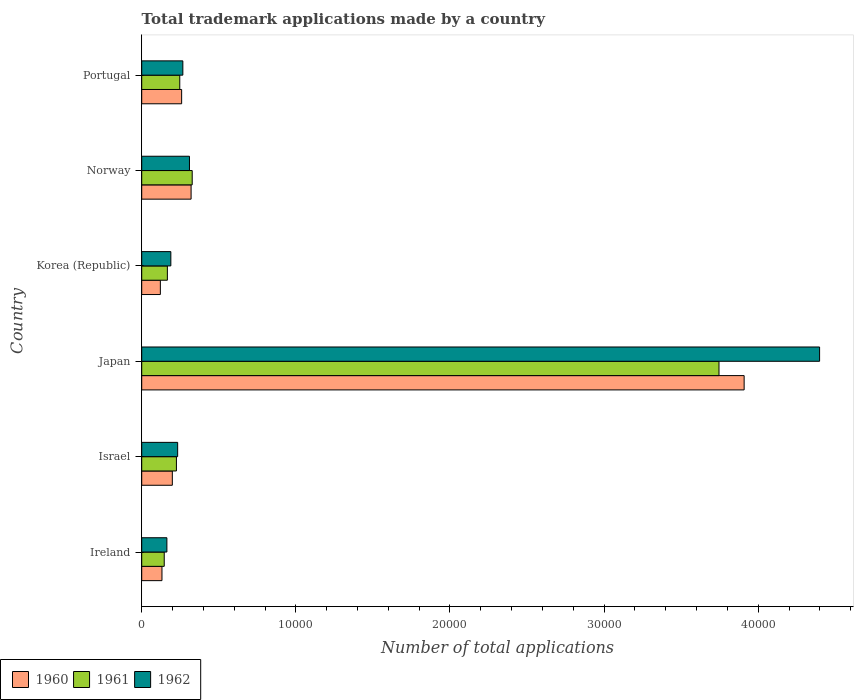How many groups of bars are there?
Give a very brief answer. 6. Are the number of bars per tick equal to the number of legend labels?
Your answer should be very brief. Yes. Are the number of bars on each tick of the Y-axis equal?
Offer a very short reply. Yes. How many bars are there on the 2nd tick from the bottom?
Offer a terse response. 3. What is the number of applications made by in 1961 in Norway?
Your answer should be very brief. 3276. Across all countries, what is the maximum number of applications made by in 1961?
Your answer should be very brief. 3.75e+04. Across all countries, what is the minimum number of applications made by in 1961?
Your answer should be very brief. 1461. What is the total number of applications made by in 1960 in the graph?
Offer a very short reply. 4.94e+04. What is the difference between the number of applications made by in 1960 in Korea (Republic) and that in Portugal?
Provide a succinct answer. -1381. What is the difference between the number of applications made by in 1961 in Israel and the number of applications made by in 1962 in Norway?
Provide a succinct answer. -846. What is the average number of applications made by in 1960 per country?
Make the answer very short. 8232. What is the difference between the number of applications made by in 1961 and number of applications made by in 1962 in Korea (Republic)?
Your answer should be compact. -225. In how many countries, is the number of applications made by in 1962 greater than 14000 ?
Provide a short and direct response. 1. What is the ratio of the number of applications made by in 1961 in Japan to that in Portugal?
Ensure brevity in your answer.  15.18. Is the number of applications made by in 1961 in Korea (Republic) less than that in Portugal?
Ensure brevity in your answer.  Yes. What is the difference between the highest and the second highest number of applications made by in 1961?
Make the answer very short. 3.42e+04. What is the difference between the highest and the lowest number of applications made by in 1962?
Offer a terse response. 4.24e+04. What does the 3rd bar from the top in Japan represents?
Provide a short and direct response. 1960. What does the 3rd bar from the bottom in Norway represents?
Keep it short and to the point. 1962. Is it the case that in every country, the sum of the number of applications made by in 1961 and number of applications made by in 1962 is greater than the number of applications made by in 1960?
Your response must be concise. Yes. How many countries are there in the graph?
Offer a terse response. 6. What is the difference between two consecutive major ticks on the X-axis?
Your answer should be very brief. 10000. Are the values on the major ticks of X-axis written in scientific E-notation?
Offer a terse response. No. Does the graph contain grids?
Offer a terse response. No. How many legend labels are there?
Your answer should be very brief. 3. How are the legend labels stacked?
Your answer should be compact. Horizontal. What is the title of the graph?
Keep it short and to the point. Total trademark applications made by a country. Does "2008" appear as one of the legend labels in the graph?
Your response must be concise. No. What is the label or title of the X-axis?
Your answer should be very brief. Number of total applications. What is the Number of total applications in 1960 in Ireland?
Your answer should be compact. 1314. What is the Number of total applications in 1961 in Ireland?
Offer a very short reply. 1461. What is the Number of total applications in 1962 in Ireland?
Keep it short and to the point. 1633. What is the Number of total applications in 1960 in Israel?
Your answer should be compact. 1986. What is the Number of total applications in 1961 in Israel?
Offer a terse response. 2252. What is the Number of total applications of 1962 in Israel?
Provide a succinct answer. 2332. What is the Number of total applications of 1960 in Japan?
Provide a short and direct response. 3.91e+04. What is the Number of total applications of 1961 in Japan?
Offer a very short reply. 3.75e+04. What is the Number of total applications in 1962 in Japan?
Offer a very short reply. 4.40e+04. What is the Number of total applications in 1960 in Korea (Republic)?
Offer a very short reply. 1209. What is the Number of total applications of 1961 in Korea (Republic)?
Offer a very short reply. 1665. What is the Number of total applications of 1962 in Korea (Republic)?
Give a very brief answer. 1890. What is the Number of total applications of 1960 in Norway?
Your response must be concise. 3204. What is the Number of total applications of 1961 in Norway?
Provide a succinct answer. 3276. What is the Number of total applications in 1962 in Norway?
Your answer should be very brief. 3098. What is the Number of total applications in 1960 in Portugal?
Offer a very short reply. 2590. What is the Number of total applications of 1961 in Portugal?
Your response must be concise. 2468. What is the Number of total applications in 1962 in Portugal?
Your answer should be compact. 2668. Across all countries, what is the maximum Number of total applications of 1960?
Keep it short and to the point. 3.91e+04. Across all countries, what is the maximum Number of total applications of 1961?
Make the answer very short. 3.75e+04. Across all countries, what is the maximum Number of total applications of 1962?
Your answer should be very brief. 4.40e+04. Across all countries, what is the minimum Number of total applications of 1960?
Keep it short and to the point. 1209. Across all countries, what is the minimum Number of total applications of 1961?
Provide a short and direct response. 1461. Across all countries, what is the minimum Number of total applications in 1962?
Give a very brief answer. 1633. What is the total Number of total applications of 1960 in the graph?
Offer a very short reply. 4.94e+04. What is the total Number of total applications of 1961 in the graph?
Offer a terse response. 4.86e+04. What is the total Number of total applications of 1962 in the graph?
Ensure brevity in your answer.  5.56e+04. What is the difference between the Number of total applications in 1960 in Ireland and that in Israel?
Keep it short and to the point. -672. What is the difference between the Number of total applications of 1961 in Ireland and that in Israel?
Your response must be concise. -791. What is the difference between the Number of total applications of 1962 in Ireland and that in Israel?
Keep it short and to the point. -699. What is the difference between the Number of total applications in 1960 in Ireland and that in Japan?
Make the answer very short. -3.78e+04. What is the difference between the Number of total applications in 1961 in Ireland and that in Japan?
Provide a succinct answer. -3.60e+04. What is the difference between the Number of total applications in 1962 in Ireland and that in Japan?
Your answer should be compact. -4.24e+04. What is the difference between the Number of total applications in 1960 in Ireland and that in Korea (Republic)?
Give a very brief answer. 105. What is the difference between the Number of total applications of 1961 in Ireland and that in Korea (Republic)?
Offer a very short reply. -204. What is the difference between the Number of total applications in 1962 in Ireland and that in Korea (Republic)?
Give a very brief answer. -257. What is the difference between the Number of total applications in 1960 in Ireland and that in Norway?
Provide a short and direct response. -1890. What is the difference between the Number of total applications in 1961 in Ireland and that in Norway?
Your response must be concise. -1815. What is the difference between the Number of total applications in 1962 in Ireland and that in Norway?
Make the answer very short. -1465. What is the difference between the Number of total applications in 1960 in Ireland and that in Portugal?
Give a very brief answer. -1276. What is the difference between the Number of total applications of 1961 in Ireland and that in Portugal?
Your answer should be very brief. -1007. What is the difference between the Number of total applications of 1962 in Ireland and that in Portugal?
Keep it short and to the point. -1035. What is the difference between the Number of total applications in 1960 in Israel and that in Japan?
Offer a very short reply. -3.71e+04. What is the difference between the Number of total applications in 1961 in Israel and that in Japan?
Provide a succinct answer. -3.52e+04. What is the difference between the Number of total applications of 1962 in Israel and that in Japan?
Your response must be concise. -4.17e+04. What is the difference between the Number of total applications of 1960 in Israel and that in Korea (Republic)?
Offer a terse response. 777. What is the difference between the Number of total applications in 1961 in Israel and that in Korea (Republic)?
Provide a short and direct response. 587. What is the difference between the Number of total applications of 1962 in Israel and that in Korea (Republic)?
Make the answer very short. 442. What is the difference between the Number of total applications in 1960 in Israel and that in Norway?
Your response must be concise. -1218. What is the difference between the Number of total applications of 1961 in Israel and that in Norway?
Offer a very short reply. -1024. What is the difference between the Number of total applications in 1962 in Israel and that in Norway?
Your answer should be compact. -766. What is the difference between the Number of total applications of 1960 in Israel and that in Portugal?
Offer a very short reply. -604. What is the difference between the Number of total applications in 1961 in Israel and that in Portugal?
Your answer should be very brief. -216. What is the difference between the Number of total applications in 1962 in Israel and that in Portugal?
Ensure brevity in your answer.  -336. What is the difference between the Number of total applications of 1960 in Japan and that in Korea (Republic)?
Offer a terse response. 3.79e+04. What is the difference between the Number of total applications in 1961 in Japan and that in Korea (Republic)?
Give a very brief answer. 3.58e+04. What is the difference between the Number of total applications in 1962 in Japan and that in Korea (Republic)?
Your answer should be very brief. 4.21e+04. What is the difference between the Number of total applications of 1960 in Japan and that in Norway?
Keep it short and to the point. 3.59e+04. What is the difference between the Number of total applications of 1961 in Japan and that in Norway?
Your response must be concise. 3.42e+04. What is the difference between the Number of total applications in 1962 in Japan and that in Norway?
Provide a succinct answer. 4.09e+04. What is the difference between the Number of total applications in 1960 in Japan and that in Portugal?
Your response must be concise. 3.65e+04. What is the difference between the Number of total applications in 1961 in Japan and that in Portugal?
Ensure brevity in your answer.  3.50e+04. What is the difference between the Number of total applications of 1962 in Japan and that in Portugal?
Provide a short and direct response. 4.13e+04. What is the difference between the Number of total applications in 1960 in Korea (Republic) and that in Norway?
Ensure brevity in your answer.  -1995. What is the difference between the Number of total applications in 1961 in Korea (Republic) and that in Norway?
Provide a short and direct response. -1611. What is the difference between the Number of total applications in 1962 in Korea (Republic) and that in Norway?
Your response must be concise. -1208. What is the difference between the Number of total applications in 1960 in Korea (Republic) and that in Portugal?
Your response must be concise. -1381. What is the difference between the Number of total applications in 1961 in Korea (Republic) and that in Portugal?
Your answer should be very brief. -803. What is the difference between the Number of total applications of 1962 in Korea (Republic) and that in Portugal?
Make the answer very short. -778. What is the difference between the Number of total applications in 1960 in Norway and that in Portugal?
Your answer should be compact. 614. What is the difference between the Number of total applications in 1961 in Norway and that in Portugal?
Provide a short and direct response. 808. What is the difference between the Number of total applications in 1962 in Norway and that in Portugal?
Provide a succinct answer. 430. What is the difference between the Number of total applications in 1960 in Ireland and the Number of total applications in 1961 in Israel?
Ensure brevity in your answer.  -938. What is the difference between the Number of total applications of 1960 in Ireland and the Number of total applications of 1962 in Israel?
Give a very brief answer. -1018. What is the difference between the Number of total applications of 1961 in Ireland and the Number of total applications of 1962 in Israel?
Offer a very short reply. -871. What is the difference between the Number of total applications of 1960 in Ireland and the Number of total applications of 1961 in Japan?
Keep it short and to the point. -3.61e+04. What is the difference between the Number of total applications of 1960 in Ireland and the Number of total applications of 1962 in Japan?
Provide a short and direct response. -4.27e+04. What is the difference between the Number of total applications of 1961 in Ireland and the Number of total applications of 1962 in Japan?
Provide a succinct answer. -4.25e+04. What is the difference between the Number of total applications in 1960 in Ireland and the Number of total applications in 1961 in Korea (Republic)?
Your answer should be very brief. -351. What is the difference between the Number of total applications in 1960 in Ireland and the Number of total applications in 1962 in Korea (Republic)?
Keep it short and to the point. -576. What is the difference between the Number of total applications in 1961 in Ireland and the Number of total applications in 1962 in Korea (Republic)?
Your answer should be very brief. -429. What is the difference between the Number of total applications in 1960 in Ireland and the Number of total applications in 1961 in Norway?
Give a very brief answer. -1962. What is the difference between the Number of total applications in 1960 in Ireland and the Number of total applications in 1962 in Norway?
Offer a terse response. -1784. What is the difference between the Number of total applications in 1961 in Ireland and the Number of total applications in 1962 in Norway?
Ensure brevity in your answer.  -1637. What is the difference between the Number of total applications of 1960 in Ireland and the Number of total applications of 1961 in Portugal?
Offer a terse response. -1154. What is the difference between the Number of total applications of 1960 in Ireland and the Number of total applications of 1962 in Portugal?
Provide a succinct answer. -1354. What is the difference between the Number of total applications in 1961 in Ireland and the Number of total applications in 1962 in Portugal?
Make the answer very short. -1207. What is the difference between the Number of total applications in 1960 in Israel and the Number of total applications in 1961 in Japan?
Make the answer very short. -3.55e+04. What is the difference between the Number of total applications of 1960 in Israel and the Number of total applications of 1962 in Japan?
Offer a terse response. -4.20e+04. What is the difference between the Number of total applications in 1961 in Israel and the Number of total applications in 1962 in Japan?
Keep it short and to the point. -4.17e+04. What is the difference between the Number of total applications of 1960 in Israel and the Number of total applications of 1961 in Korea (Republic)?
Give a very brief answer. 321. What is the difference between the Number of total applications of 1960 in Israel and the Number of total applications of 1962 in Korea (Republic)?
Your answer should be very brief. 96. What is the difference between the Number of total applications of 1961 in Israel and the Number of total applications of 1962 in Korea (Republic)?
Offer a terse response. 362. What is the difference between the Number of total applications in 1960 in Israel and the Number of total applications in 1961 in Norway?
Ensure brevity in your answer.  -1290. What is the difference between the Number of total applications in 1960 in Israel and the Number of total applications in 1962 in Norway?
Your response must be concise. -1112. What is the difference between the Number of total applications of 1961 in Israel and the Number of total applications of 1962 in Norway?
Offer a very short reply. -846. What is the difference between the Number of total applications in 1960 in Israel and the Number of total applications in 1961 in Portugal?
Keep it short and to the point. -482. What is the difference between the Number of total applications in 1960 in Israel and the Number of total applications in 1962 in Portugal?
Your answer should be compact. -682. What is the difference between the Number of total applications in 1961 in Israel and the Number of total applications in 1962 in Portugal?
Your answer should be very brief. -416. What is the difference between the Number of total applications of 1960 in Japan and the Number of total applications of 1961 in Korea (Republic)?
Ensure brevity in your answer.  3.74e+04. What is the difference between the Number of total applications in 1960 in Japan and the Number of total applications in 1962 in Korea (Republic)?
Ensure brevity in your answer.  3.72e+04. What is the difference between the Number of total applications in 1961 in Japan and the Number of total applications in 1962 in Korea (Republic)?
Provide a succinct answer. 3.56e+04. What is the difference between the Number of total applications of 1960 in Japan and the Number of total applications of 1961 in Norway?
Your answer should be compact. 3.58e+04. What is the difference between the Number of total applications of 1960 in Japan and the Number of total applications of 1962 in Norway?
Give a very brief answer. 3.60e+04. What is the difference between the Number of total applications in 1961 in Japan and the Number of total applications in 1962 in Norway?
Ensure brevity in your answer.  3.44e+04. What is the difference between the Number of total applications in 1960 in Japan and the Number of total applications in 1961 in Portugal?
Ensure brevity in your answer.  3.66e+04. What is the difference between the Number of total applications of 1960 in Japan and the Number of total applications of 1962 in Portugal?
Make the answer very short. 3.64e+04. What is the difference between the Number of total applications of 1961 in Japan and the Number of total applications of 1962 in Portugal?
Your answer should be very brief. 3.48e+04. What is the difference between the Number of total applications of 1960 in Korea (Republic) and the Number of total applications of 1961 in Norway?
Make the answer very short. -2067. What is the difference between the Number of total applications of 1960 in Korea (Republic) and the Number of total applications of 1962 in Norway?
Ensure brevity in your answer.  -1889. What is the difference between the Number of total applications in 1961 in Korea (Republic) and the Number of total applications in 1962 in Norway?
Make the answer very short. -1433. What is the difference between the Number of total applications in 1960 in Korea (Republic) and the Number of total applications in 1961 in Portugal?
Your answer should be very brief. -1259. What is the difference between the Number of total applications in 1960 in Korea (Republic) and the Number of total applications in 1962 in Portugal?
Ensure brevity in your answer.  -1459. What is the difference between the Number of total applications in 1961 in Korea (Republic) and the Number of total applications in 1962 in Portugal?
Make the answer very short. -1003. What is the difference between the Number of total applications of 1960 in Norway and the Number of total applications of 1961 in Portugal?
Keep it short and to the point. 736. What is the difference between the Number of total applications of 1960 in Norway and the Number of total applications of 1962 in Portugal?
Offer a very short reply. 536. What is the difference between the Number of total applications in 1961 in Norway and the Number of total applications in 1962 in Portugal?
Offer a very short reply. 608. What is the average Number of total applications in 1960 per country?
Offer a terse response. 8232. What is the average Number of total applications of 1961 per country?
Your answer should be very brief. 8096.67. What is the average Number of total applications of 1962 per country?
Make the answer very short. 9267.67. What is the difference between the Number of total applications in 1960 and Number of total applications in 1961 in Ireland?
Ensure brevity in your answer.  -147. What is the difference between the Number of total applications in 1960 and Number of total applications in 1962 in Ireland?
Your answer should be very brief. -319. What is the difference between the Number of total applications of 1961 and Number of total applications of 1962 in Ireland?
Ensure brevity in your answer.  -172. What is the difference between the Number of total applications in 1960 and Number of total applications in 1961 in Israel?
Provide a short and direct response. -266. What is the difference between the Number of total applications in 1960 and Number of total applications in 1962 in Israel?
Give a very brief answer. -346. What is the difference between the Number of total applications of 1961 and Number of total applications of 1962 in Israel?
Your response must be concise. -80. What is the difference between the Number of total applications of 1960 and Number of total applications of 1961 in Japan?
Your answer should be very brief. 1631. What is the difference between the Number of total applications in 1960 and Number of total applications in 1962 in Japan?
Keep it short and to the point. -4896. What is the difference between the Number of total applications of 1961 and Number of total applications of 1962 in Japan?
Ensure brevity in your answer.  -6527. What is the difference between the Number of total applications of 1960 and Number of total applications of 1961 in Korea (Republic)?
Ensure brevity in your answer.  -456. What is the difference between the Number of total applications of 1960 and Number of total applications of 1962 in Korea (Republic)?
Your answer should be very brief. -681. What is the difference between the Number of total applications in 1961 and Number of total applications in 1962 in Korea (Republic)?
Your response must be concise. -225. What is the difference between the Number of total applications of 1960 and Number of total applications of 1961 in Norway?
Give a very brief answer. -72. What is the difference between the Number of total applications in 1960 and Number of total applications in 1962 in Norway?
Provide a short and direct response. 106. What is the difference between the Number of total applications of 1961 and Number of total applications of 1962 in Norway?
Provide a short and direct response. 178. What is the difference between the Number of total applications in 1960 and Number of total applications in 1961 in Portugal?
Your response must be concise. 122. What is the difference between the Number of total applications of 1960 and Number of total applications of 1962 in Portugal?
Your answer should be very brief. -78. What is the difference between the Number of total applications in 1961 and Number of total applications in 1962 in Portugal?
Keep it short and to the point. -200. What is the ratio of the Number of total applications of 1960 in Ireland to that in Israel?
Offer a terse response. 0.66. What is the ratio of the Number of total applications in 1961 in Ireland to that in Israel?
Provide a succinct answer. 0.65. What is the ratio of the Number of total applications in 1962 in Ireland to that in Israel?
Provide a short and direct response. 0.7. What is the ratio of the Number of total applications of 1960 in Ireland to that in Japan?
Your response must be concise. 0.03. What is the ratio of the Number of total applications of 1961 in Ireland to that in Japan?
Offer a very short reply. 0.04. What is the ratio of the Number of total applications of 1962 in Ireland to that in Japan?
Your answer should be very brief. 0.04. What is the ratio of the Number of total applications in 1960 in Ireland to that in Korea (Republic)?
Your answer should be very brief. 1.09. What is the ratio of the Number of total applications of 1961 in Ireland to that in Korea (Republic)?
Keep it short and to the point. 0.88. What is the ratio of the Number of total applications in 1962 in Ireland to that in Korea (Republic)?
Offer a very short reply. 0.86. What is the ratio of the Number of total applications in 1960 in Ireland to that in Norway?
Your answer should be very brief. 0.41. What is the ratio of the Number of total applications of 1961 in Ireland to that in Norway?
Provide a succinct answer. 0.45. What is the ratio of the Number of total applications in 1962 in Ireland to that in Norway?
Make the answer very short. 0.53. What is the ratio of the Number of total applications of 1960 in Ireland to that in Portugal?
Provide a succinct answer. 0.51. What is the ratio of the Number of total applications of 1961 in Ireland to that in Portugal?
Give a very brief answer. 0.59. What is the ratio of the Number of total applications of 1962 in Ireland to that in Portugal?
Provide a succinct answer. 0.61. What is the ratio of the Number of total applications of 1960 in Israel to that in Japan?
Offer a terse response. 0.05. What is the ratio of the Number of total applications of 1961 in Israel to that in Japan?
Keep it short and to the point. 0.06. What is the ratio of the Number of total applications in 1962 in Israel to that in Japan?
Provide a succinct answer. 0.05. What is the ratio of the Number of total applications of 1960 in Israel to that in Korea (Republic)?
Your answer should be compact. 1.64. What is the ratio of the Number of total applications in 1961 in Israel to that in Korea (Republic)?
Offer a terse response. 1.35. What is the ratio of the Number of total applications in 1962 in Israel to that in Korea (Republic)?
Ensure brevity in your answer.  1.23. What is the ratio of the Number of total applications in 1960 in Israel to that in Norway?
Provide a short and direct response. 0.62. What is the ratio of the Number of total applications in 1961 in Israel to that in Norway?
Your answer should be very brief. 0.69. What is the ratio of the Number of total applications in 1962 in Israel to that in Norway?
Offer a terse response. 0.75. What is the ratio of the Number of total applications of 1960 in Israel to that in Portugal?
Give a very brief answer. 0.77. What is the ratio of the Number of total applications in 1961 in Israel to that in Portugal?
Provide a short and direct response. 0.91. What is the ratio of the Number of total applications in 1962 in Israel to that in Portugal?
Make the answer very short. 0.87. What is the ratio of the Number of total applications of 1960 in Japan to that in Korea (Republic)?
Provide a short and direct response. 32.33. What is the ratio of the Number of total applications of 1961 in Japan to that in Korea (Republic)?
Offer a terse response. 22.5. What is the ratio of the Number of total applications of 1962 in Japan to that in Korea (Republic)?
Make the answer very short. 23.27. What is the ratio of the Number of total applications of 1960 in Japan to that in Norway?
Keep it short and to the point. 12.2. What is the ratio of the Number of total applications of 1961 in Japan to that in Norway?
Give a very brief answer. 11.43. What is the ratio of the Number of total applications in 1962 in Japan to that in Norway?
Provide a succinct answer. 14.2. What is the ratio of the Number of total applications of 1960 in Japan to that in Portugal?
Provide a succinct answer. 15.09. What is the ratio of the Number of total applications of 1961 in Japan to that in Portugal?
Offer a terse response. 15.18. What is the ratio of the Number of total applications of 1962 in Japan to that in Portugal?
Make the answer very short. 16.49. What is the ratio of the Number of total applications of 1960 in Korea (Republic) to that in Norway?
Your answer should be compact. 0.38. What is the ratio of the Number of total applications in 1961 in Korea (Republic) to that in Norway?
Keep it short and to the point. 0.51. What is the ratio of the Number of total applications of 1962 in Korea (Republic) to that in Norway?
Offer a very short reply. 0.61. What is the ratio of the Number of total applications in 1960 in Korea (Republic) to that in Portugal?
Your answer should be very brief. 0.47. What is the ratio of the Number of total applications in 1961 in Korea (Republic) to that in Portugal?
Offer a very short reply. 0.67. What is the ratio of the Number of total applications in 1962 in Korea (Republic) to that in Portugal?
Offer a terse response. 0.71. What is the ratio of the Number of total applications in 1960 in Norway to that in Portugal?
Your answer should be very brief. 1.24. What is the ratio of the Number of total applications in 1961 in Norway to that in Portugal?
Offer a very short reply. 1.33. What is the ratio of the Number of total applications of 1962 in Norway to that in Portugal?
Provide a short and direct response. 1.16. What is the difference between the highest and the second highest Number of total applications in 1960?
Give a very brief answer. 3.59e+04. What is the difference between the highest and the second highest Number of total applications of 1961?
Offer a terse response. 3.42e+04. What is the difference between the highest and the second highest Number of total applications in 1962?
Offer a terse response. 4.09e+04. What is the difference between the highest and the lowest Number of total applications in 1960?
Provide a short and direct response. 3.79e+04. What is the difference between the highest and the lowest Number of total applications in 1961?
Provide a succinct answer. 3.60e+04. What is the difference between the highest and the lowest Number of total applications in 1962?
Make the answer very short. 4.24e+04. 